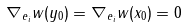Convert formula to latex. <formula><loc_0><loc_0><loc_500><loc_500>\nabla _ { e _ { i } } w ( y _ { 0 } ) = \nabla _ { e _ { i } } w ( x _ { 0 } ) = 0</formula> 